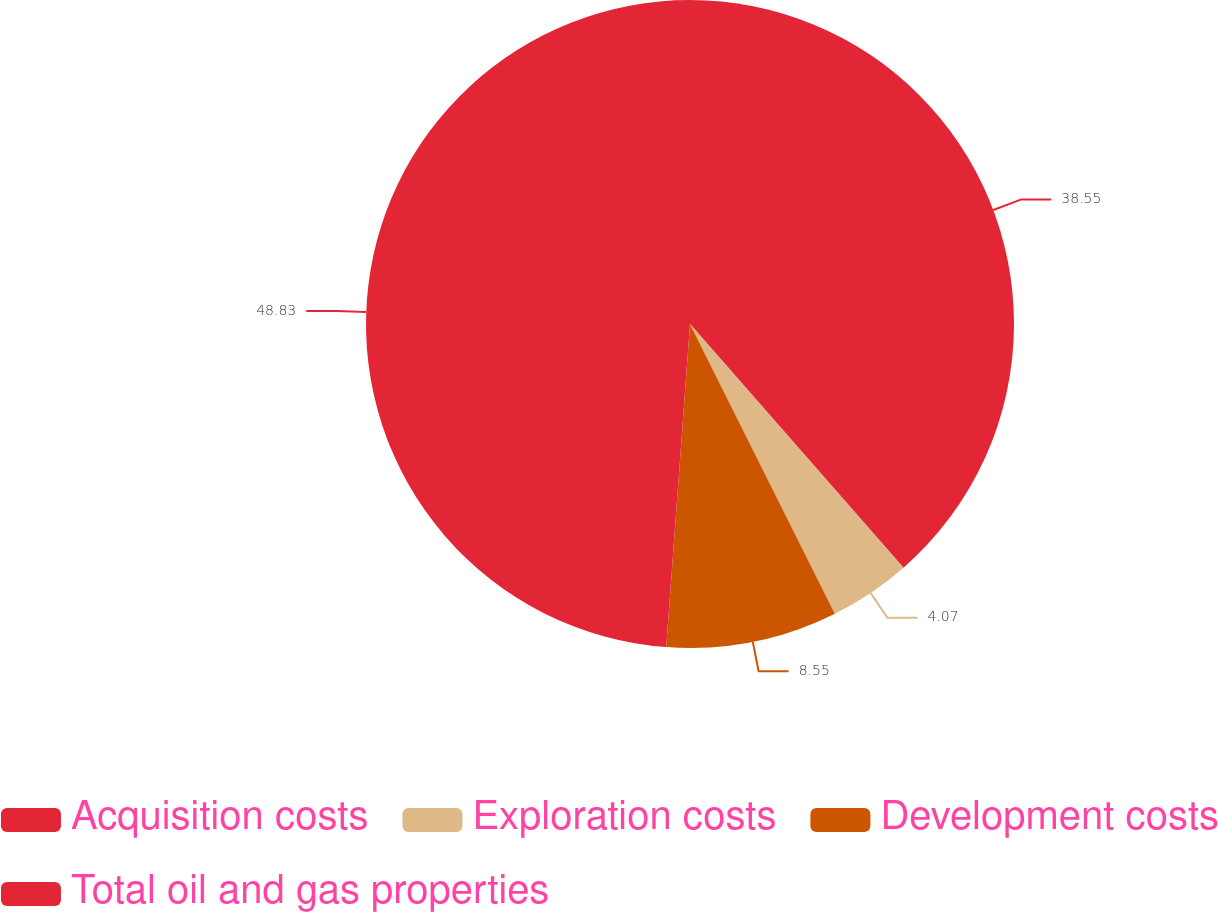Convert chart to OTSL. <chart><loc_0><loc_0><loc_500><loc_500><pie_chart><fcel>Acquisition costs<fcel>Exploration costs<fcel>Development costs<fcel>Total oil and gas properties<nl><fcel>38.55%<fcel>4.07%<fcel>8.55%<fcel>48.83%<nl></chart> 